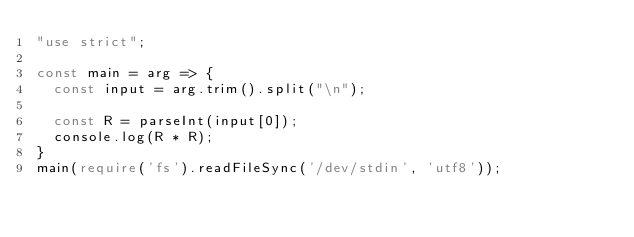<code> <loc_0><loc_0><loc_500><loc_500><_TypeScript_>"use strict";

const main = arg => {
  const input = arg.trim().split("\n");

  const R = parseInt(input[0]);
  console.log(R * R);
}
main(require('fs').readFileSync('/dev/stdin', 'utf8'));</code> 